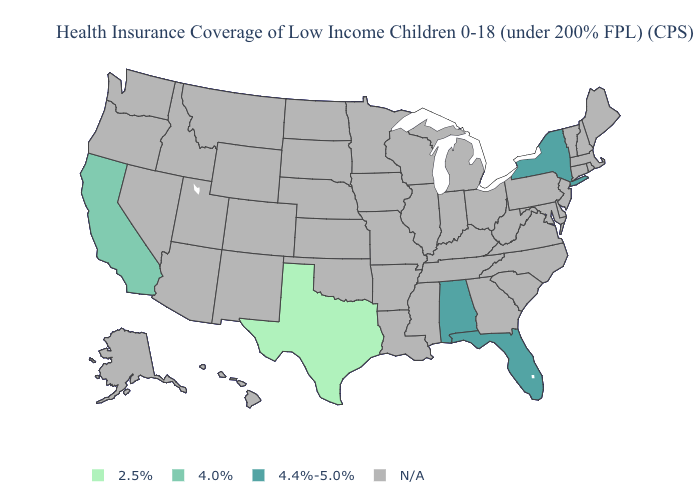Is the legend a continuous bar?
Concise answer only. No. What is the value of Rhode Island?
Short answer required. N/A. Name the states that have a value in the range N/A?
Write a very short answer. Alaska, Arizona, Arkansas, Colorado, Connecticut, Delaware, Georgia, Hawaii, Idaho, Illinois, Indiana, Iowa, Kansas, Kentucky, Louisiana, Maine, Maryland, Massachusetts, Michigan, Minnesota, Mississippi, Missouri, Montana, Nebraska, Nevada, New Hampshire, New Jersey, New Mexico, North Carolina, North Dakota, Ohio, Oklahoma, Oregon, Pennsylvania, Rhode Island, South Carolina, South Dakota, Tennessee, Utah, Vermont, Virginia, Washington, West Virginia, Wisconsin, Wyoming. Name the states that have a value in the range 2.5%?
Be succinct. Texas. What is the value of Maine?
Short answer required. N/A. What is the value of Utah?
Keep it brief. N/A. What is the highest value in the USA?
Keep it brief. 4.4%-5.0%. Which states hav the highest value in the West?
Concise answer only. California. Name the states that have a value in the range 2.5%?
Give a very brief answer. Texas. Name the states that have a value in the range N/A?
Quick response, please. Alaska, Arizona, Arkansas, Colorado, Connecticut, Delaware, Georgia, Hawaii, Idaho, Illinois, Indiana, Iowa, Kansas, Kentucky, Louisiana, Maine, Maryland, Massachusetts, Michigan, Minnesota, Mississippi, Missouri, Montana, Nebraska, Nevada, New Hampshire, New Jersey, New Mexico, North Carolina, North Dakota, Ohio, Oklahoma, Oregon, Pennsylvania, Rhode Island, South Carolina, South Dakota, Tennessee, Utah, Vermont, Virginia, Washington, West Virginia, Wisconsin, Wyoming. What is the highest value in the USA?
Write a very short answer. 4.4%-5.0%. What is the value of Maryland?
Keep it brief. N/A. 